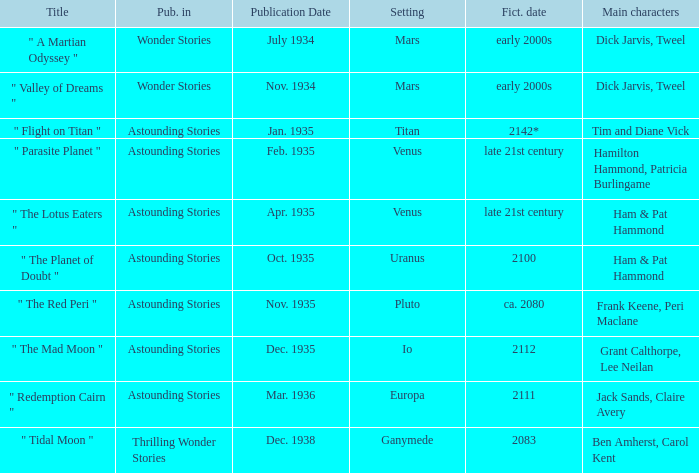Name the title when the main characters are grant calthorpe, lee neilan and the published in of astounding stories " The Mad Moon ". 